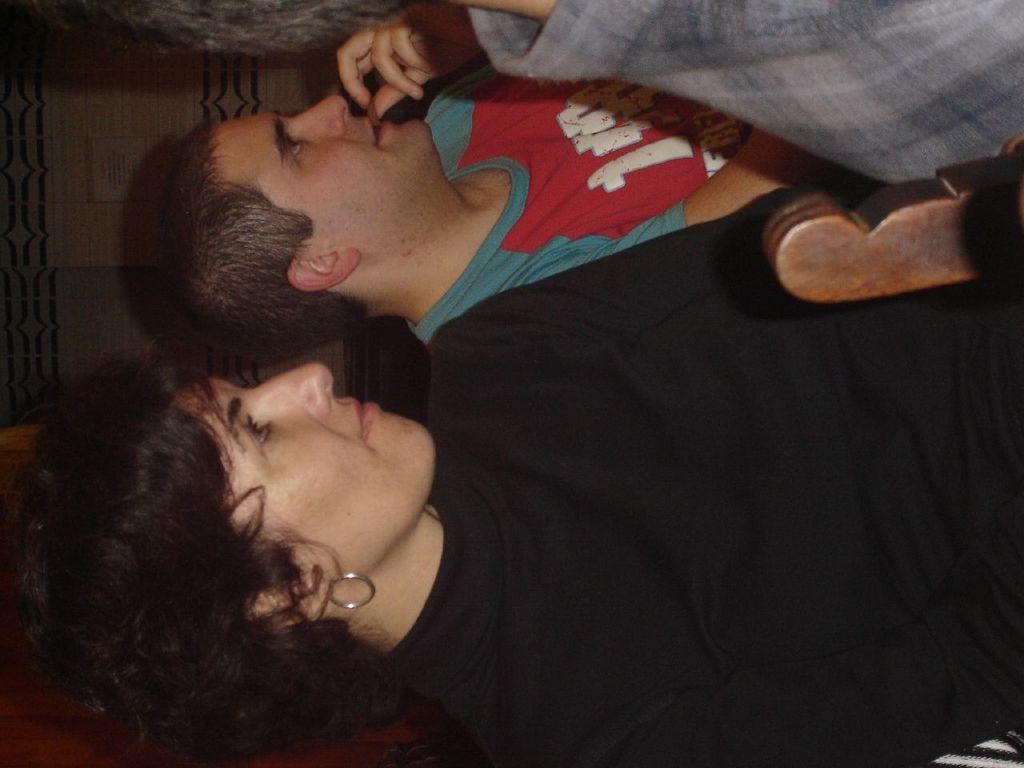How many people are present in the image? There are three people in the image, including a man and a woman. What is the gender of the person in front of the man and woman? The gender of the person in front of the man and woman cannot be determined from the image. What type of object can be seen in the image? There is a wooden object in the image. What type of pets are visible in the image? There are no pets visible in the image. How does the nerve affect the interaction between the man and woman in the image? There is no mention of a nerve or any interaction between the man and woman in the image. 